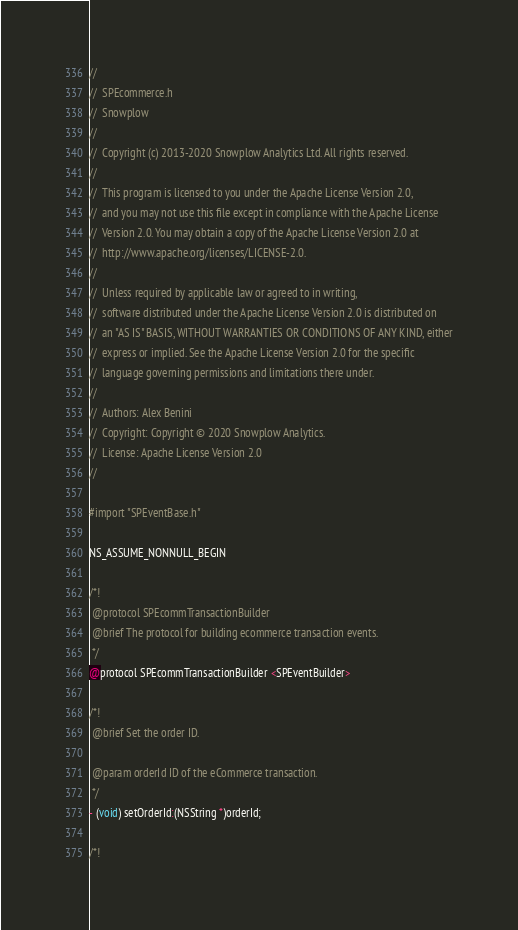<code> <loc_0><loc_0><loc_500><loc_500><_C_>//
//  SPEcommerce.h
//  Snowplow
//
//  Copyright (c) 2013-2020 Snowplow Analytics Ltd. All rights reserved.
//
//  This program is licensed to you under the Apache License Version 2.0,
//  and you may not use this file except in compliance with the Apache License
//  Version 2.0. You may obtain a copy of the Apache License Version 2.0 at
//  http://www.apache.org/licenses/LICENSE-2.0.
//
//  Unless required by applicable law or agreed to in writing,
//  software distributed under the Apache License Version 2.0 is distributed on
//  an "AS IS" BASIS, WITHOUT WARRANTIES OR CONDITIONS OF ANY KIND, either
//  express or implied. See the Apache License Version 2.0 for the specific
//  language governing permissions and limitations there under.
//
//  Authors: Alex Benini
//  Copyright: Copyright © 2020 Snowplow Analytics.
//  License: Apache License Version 2.0
//

#import "SPEventBase.h"

NS_ASSUME_NONNULL_BEGIN

/*!
 @protocol SPEcommTransactionBuilder
 @brief The protocol for building ecommerce transaction events.
 */
@protocol SPEcommTransactionBuilder <SPEventBuilder>

/*!
 @brief Set the order ID.

 @param orderId ID of the eCommerce transaction.
 */
- (void) setOrderId:(NSString *)orderId;

/*!</code> 